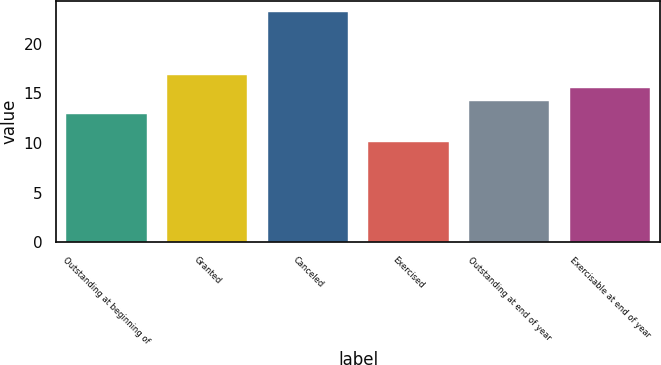Convert chart to OTSL. <chart><loc_0><loc_0><loc_500><loc_500><bar_chart><fcel>Outstanding at beginning of<fcel>Granted<fcel>Canceled<fcel>Exercised<fcel>Outstanding at end of year<fcel>Exercisable at end of year<nl><fcel>12.92<fcel>16.85<fcel>23.2<fcel>10.08<fcel>14.23<fcel>15.54<nl></chart> 